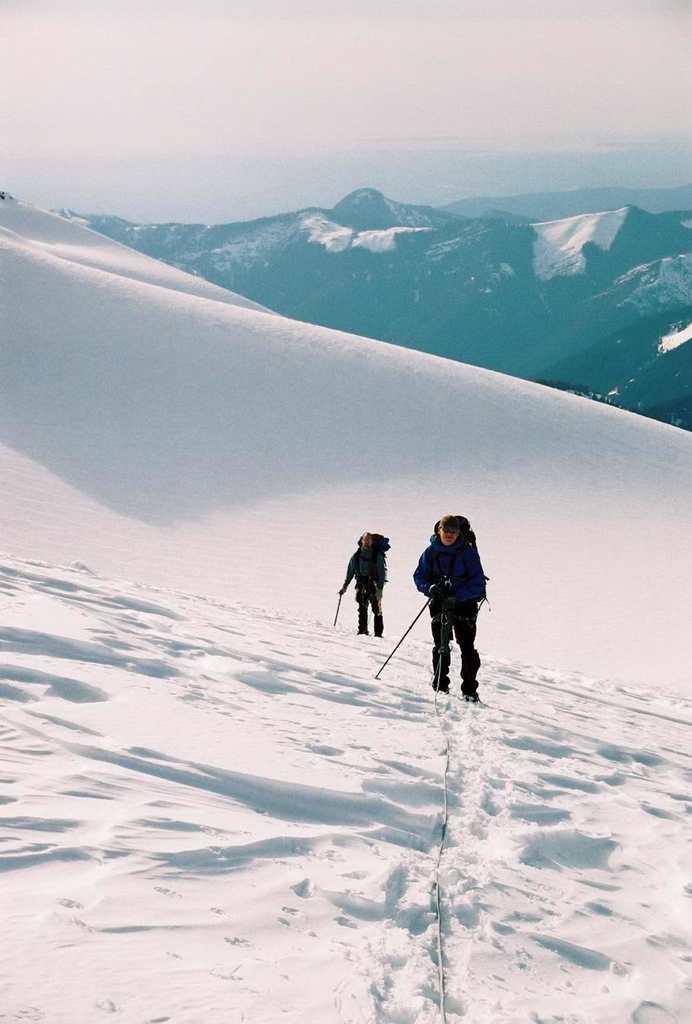Please provide a concise description of this image. In this image, there is snow in white color, there are some people walking and they are holding ski sticks, at the background there are some mountains and at the top there is a sky. 